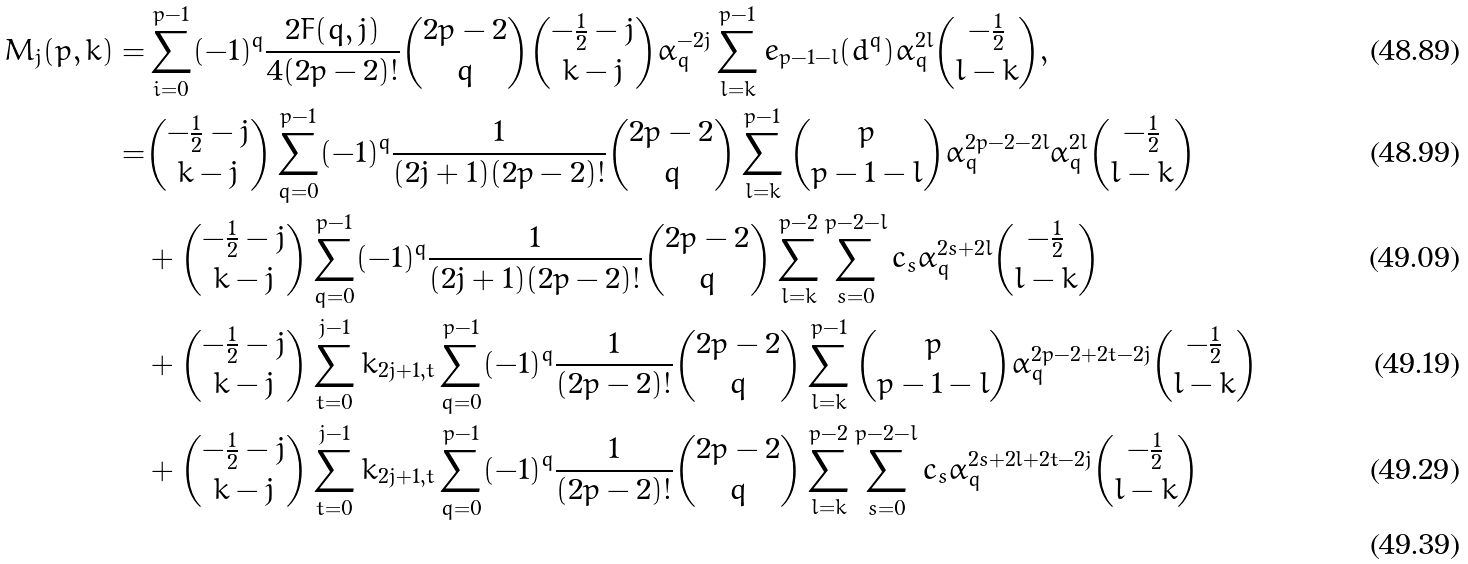<formula> <loc_0><loc_0><loc_500><loc_500>M _ { j } ( p , k ) = & \sum ^ { p - 1 } _ { i = 0 } ( - 1 ) ^ { q } \frac { 2 F ( q , j ) } { 4 ( 2 p - 2 ) ! } \binom { 2 p - 2 } { q } \binom { - \frac { 1 } { 2 } - j } { k - j } \alpha _ { q } ^ { - 2 j } \sum ^ { p - 1 } _ { l = k } e _ { p - 1 - l } ( d ^ { q } ) \alpha _ { q } ^ { 2 l } \binom { - \frac { 1 } { 2 } } { l - k } , \\ = & \binom { - \frac { 1 } { 2 } - j } { k - j } \sum ^ { p - 1 } _ { q = 0 } ( - 1 ) ^ { q } \frac { 1 } { ( 2 j + 1 ) ( 2 p - 2 ) ! } \binom { 2 p - 2 } { q } \sum ^ { p - 1 } _ { l = k } \binom { p } { p - 1 - l } \alpha _ { q } ^ { 2 p - 2 - 2 l } \alpha _ { q } ^ { 2 l } \binom { - \frac { 1 } { 2 } } { l - k } \\ & + \binom { - \frac { 1 } { 2 } - j } { k - j } \sum ^ { p - 1 } _ { q = 0 } ( - 1 ) ^ { q } \frac { 1 } { ( 2 j + 1 ) ( 2 p - 2 ) ! } \binom { 2 p - 2 } { q } \sum ^ { p - 2 } _ { l = k } \sum ^ { p - 2 - l } _ { s = 0 } c _ { s } \alpha _ { q } ^ { 2 s + 2 l } \binom { - \frac { 1 } { 2 } } { l - k } \\ & + \binom { - \frac { 1 } { 2 } - j } { k - j } \sum ^ { j - 1 } _ { t = 0 } k _ { 2 j + 1 , t } \sum ^ { p - 1 } _ { q = 0 } ( - 1 ) ^ { q } \frac { 1 } { ( 2 p - 2 ) ! } \binom { 2 p - 2 } { q } \sum ^ { p - 1 } _ { l = k } \binom { p } { p - 1 - l } \alpha _ { q } ^ { 2 p - 2 + 2 t - 2 j } \binom { - \frac { 1 } { 2 } } { l - k } \\ & + \binom { - \frac { 1 } { 2 } - j } { k - j } \sum ^ { j - 1 } _ { t = 0 } k _ { 2 j + 1 , t } \sum ^ { p - 1 } _ { q = 0 } ( - 1 ) ^ { q } \frac { 1 } { ( 2 p - 2 ) ! } \binom { 2 p - 2 } { q } \sum ^ { p - 2 } _ { l = k } \sum ^ { p - 2 - l } _ { s = 0 } c _ { s } \alpha _ { q } ^ { 2 s + 2 l + 2 t - 2 j } \binom { - \frac { 1 } { 2 } } { l - k } \\</formula> 